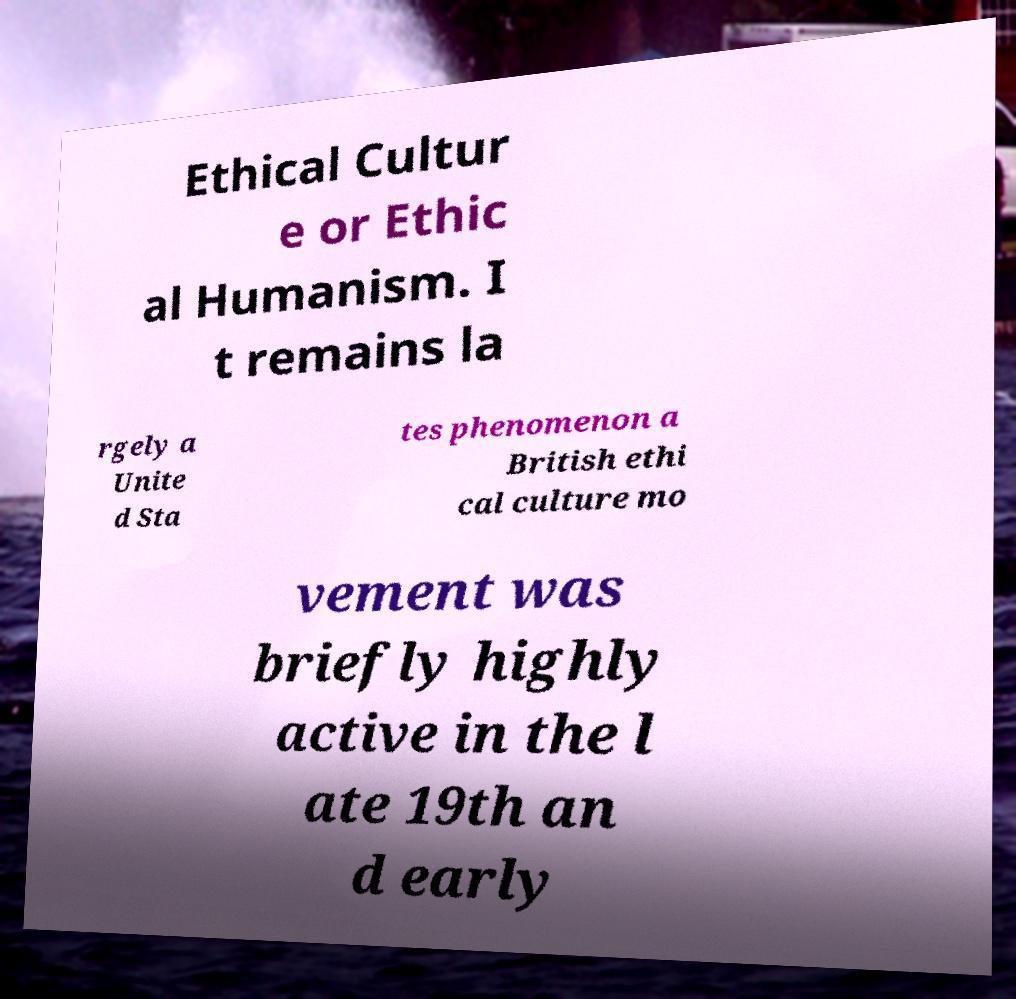Please read and relay the text visible in this image. What does it say? Ethical Cultur e or Ethic al Humanism. I t remains la rgely a Unite d Sta tes phenomenon a British ethi cal culture mo vement was briefly highly active in the l ate 19th an d early 